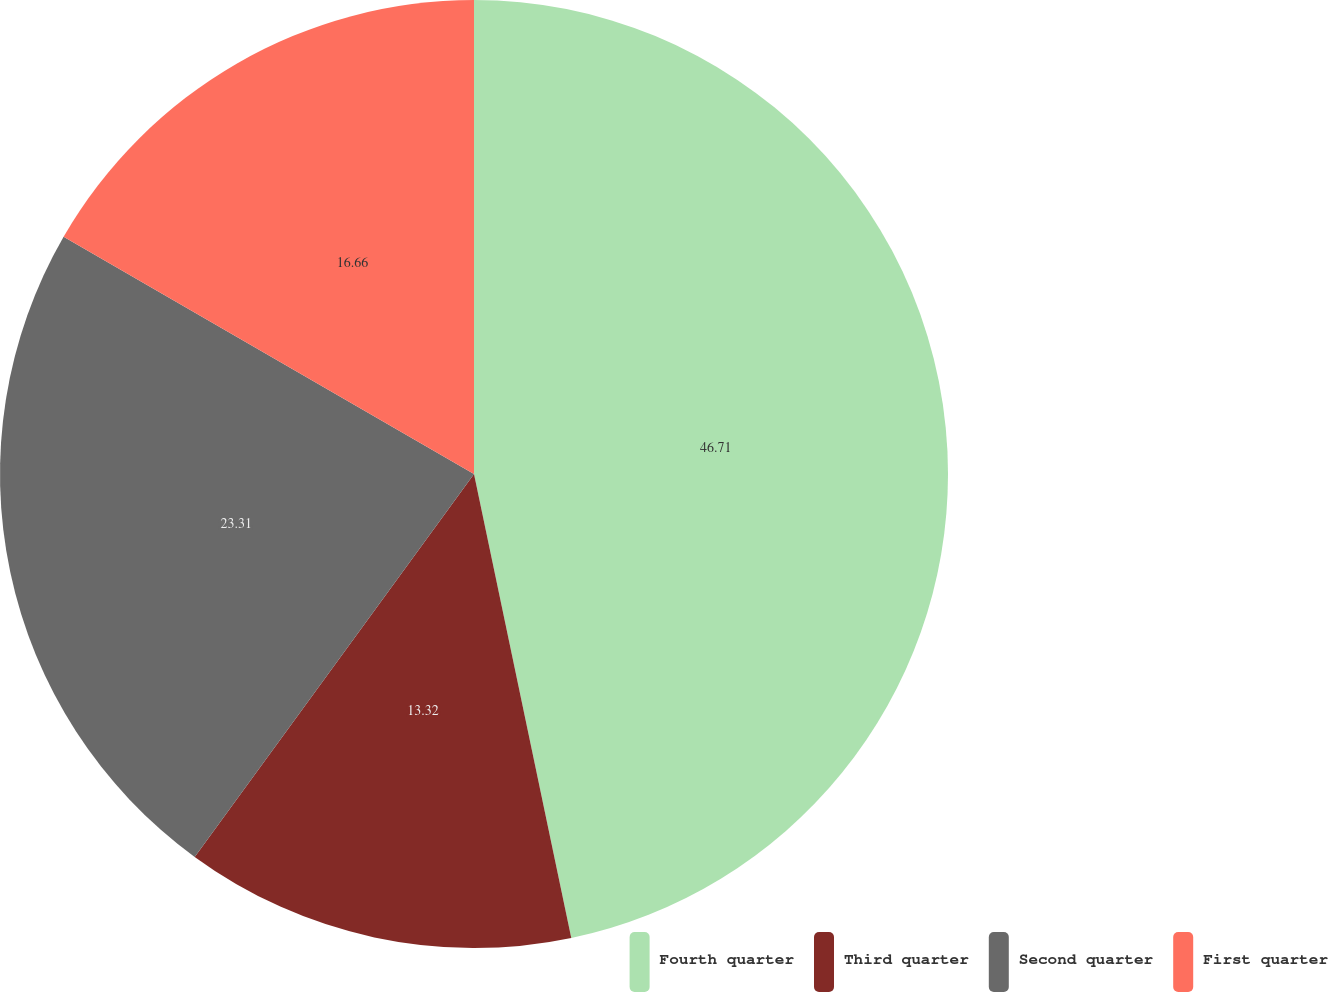Convert chart. <chart><loc_0><loc_0><loc_500><loc_500><pie_chart><fcel>Fourth quarter<fcel>Third quarter<fcel>Second quarter<fcel>First quarter<nl><fcel>46.71%<fcel>13.32%<fcel>23.31%<fcel>16.66%<nl></chart> 